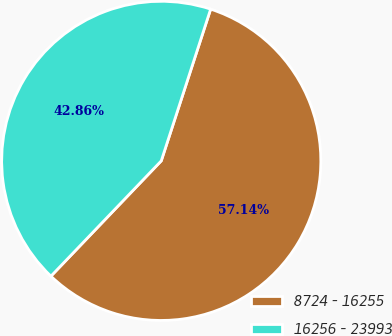Convert chart to OTSL. <chart><loc_0><loc_0><loc_500><loc_500><pie_chart><fcel>8724 - 16255<fcel>16256 - 23993<nl><fcel>57.14%<fcel>42.86%<nl></chart> 